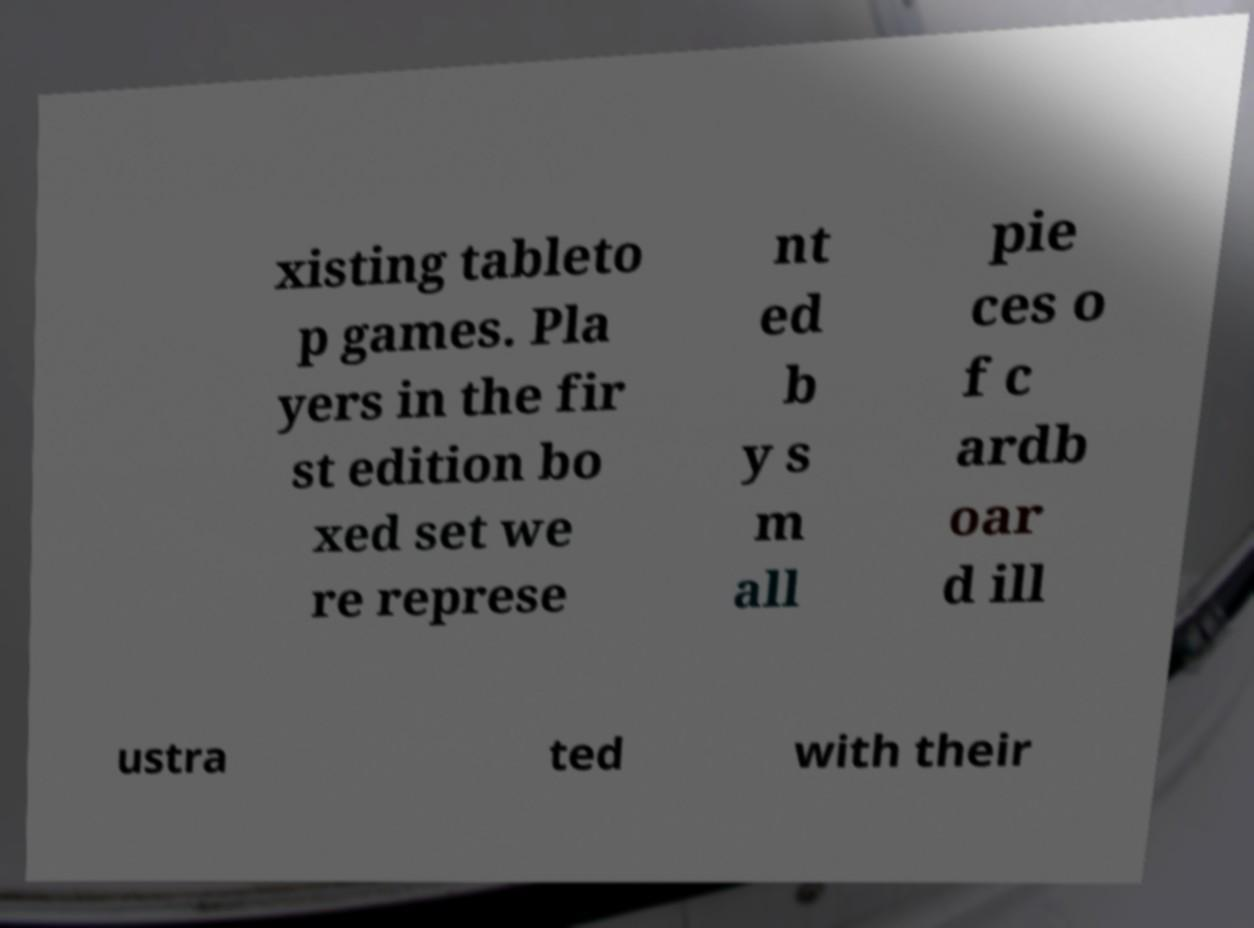Please identify and transcribe the text found in this image. xisting tableto p games. Pla yers in the fir st edition bo xed set we re represe nt ed b y s m all pie ces o f c ardb oar d ill ustra ted with their 